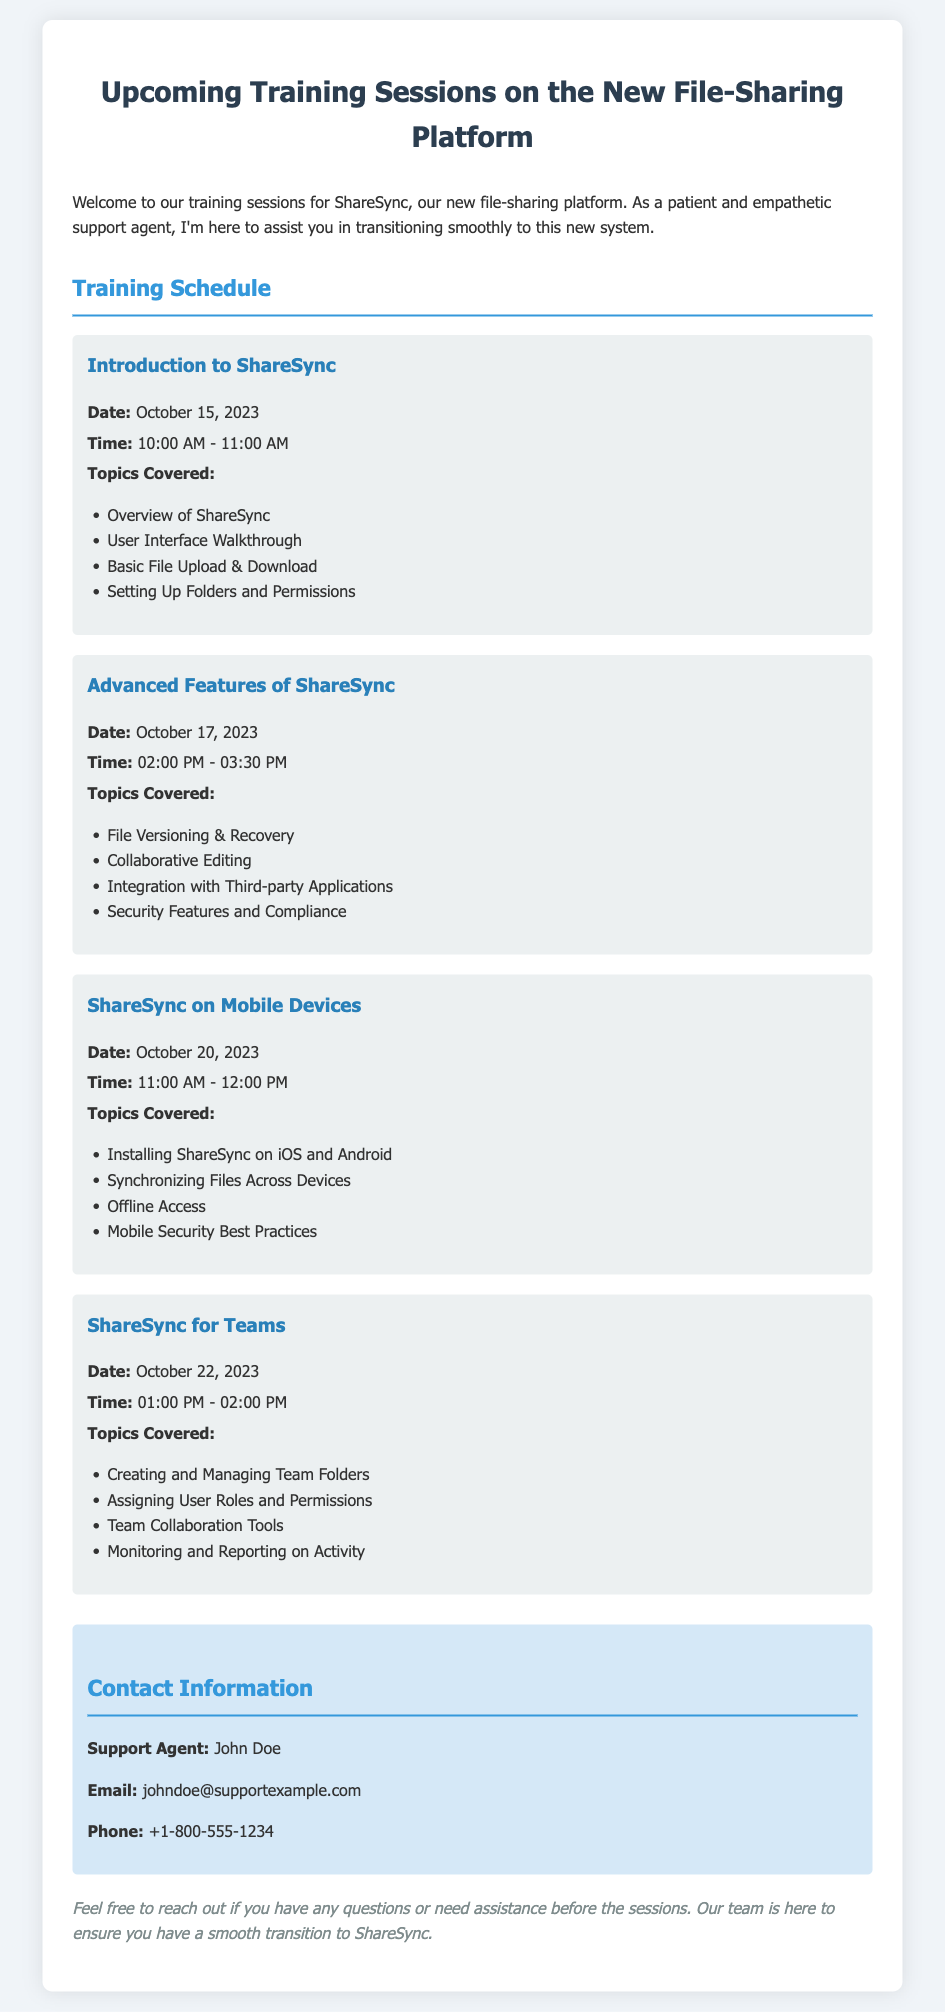What is the date of the first training session? The date of the first training session can be found in the section titled "Training Schedule," where it lists the introductory session.
Answer: October 15, 2023 What is the topic of the training on October 20, 2023? The topic for the training session on October 20, 2023, is listed in the schedule, focusing on ShareSync mobile usage.
Answer: ShareSync on Mobile Devices What time does the session on Advanced Features of ShareSync start? The starting time for the session on Advanced Features can be found under the respective training session details.
Answer: 02:00 PM How many topics are covered in the Introduction to ShareSync session? The number of topics can be determined by counting the listed items under the Introduction to ShareSync session.
Answer: 4 Who is the support agent for the training sessions? The support agent's name is specified in the contact information section.
Answer: John Doe What is the duration of the ShareSync for Teams session? The duration can be inferred from the start and end times of the session listed.
Answer: 1 hour What is the email address for support inquiries? The email for support can be extracted from the contact information section.
Answer: johndoe@supportexample.com What is discussed in the Advanced Features session regarding security? The security-related topic can be found in the list of topics covered for the Advanced Features session.
Answer: Security Features and Compliance When is the last training session scheduled? The last training session date is included in the training schedule section.
Answer: October 22, 2023 